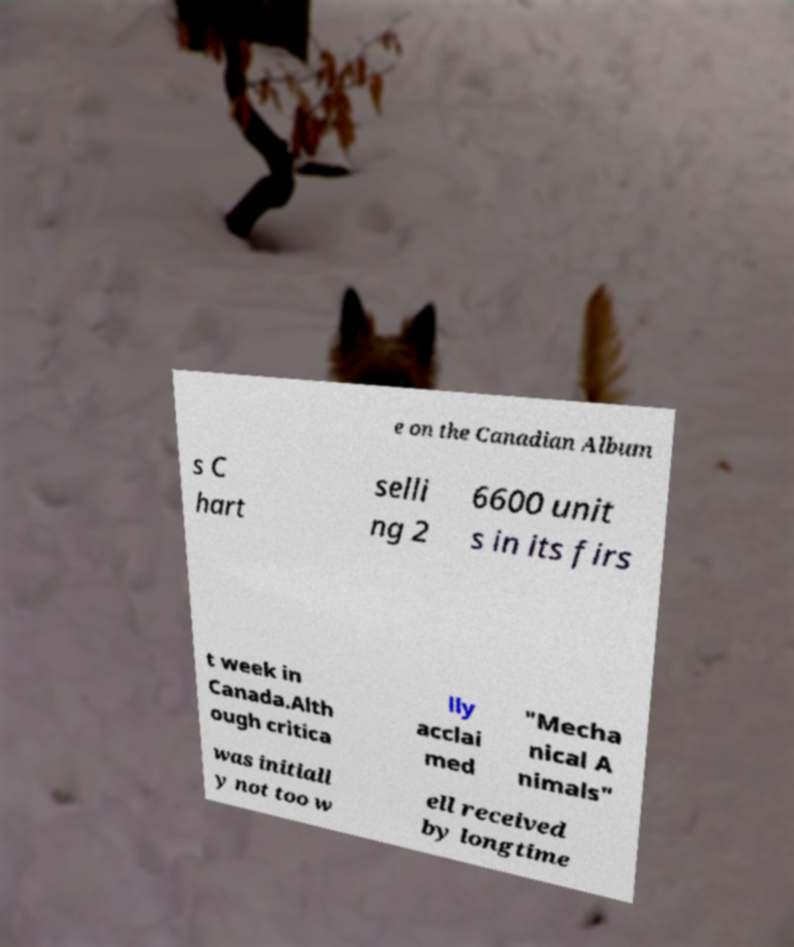Could you extract and type out the text from this image? e on the Canadian Album s C hart selli ng 2 6600 unit s in its firs t week in Canada.Alth ough critica lly acclai med "Mecha nical A nimals" was initiall y not too w ell received by longtime 